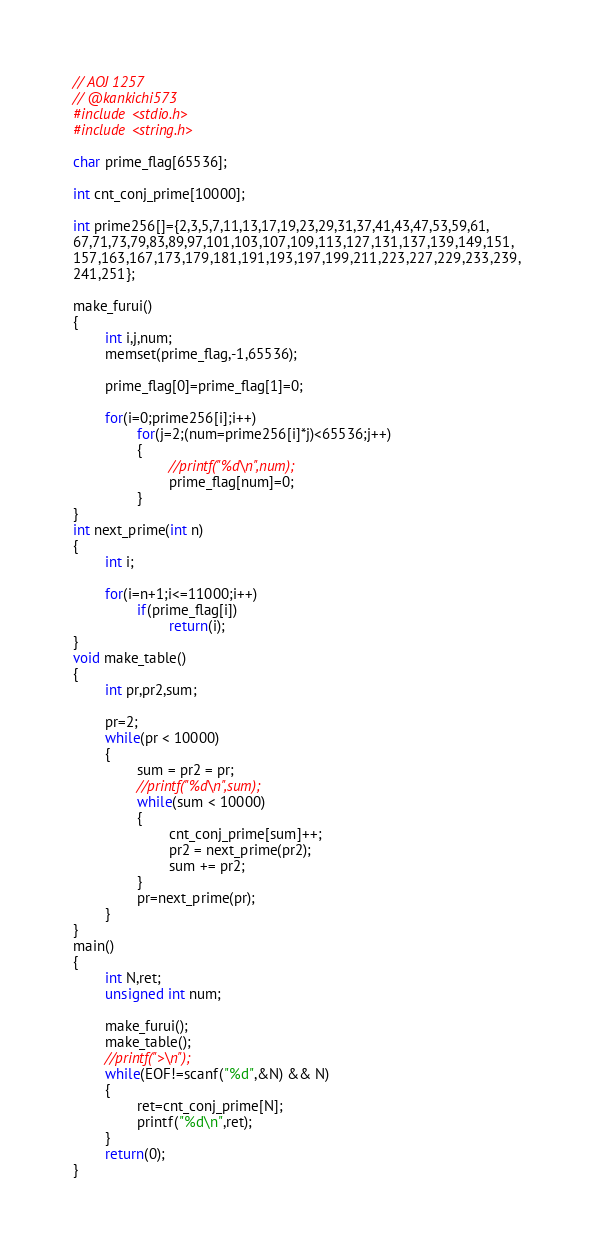Convert code to text. <code><loc_0><loc_0><loc_500><loc_500><_C_>// AOJ 1257
// @kankichi573
#include <stdio.h>
#include <string.h>

char prime_flag[65536];

int cnt_conj_prime[10000];

int prime256[]={2,3,5,7,11,13,17,19,23,29,31,37,41,43,47,53,59,61,
67,71,73,79,83,89,97,101,103,107,109,113,127,131,137,139,149,151,
157,163,167,173,179,181,191,193,197,199,211,223,227,229,233,239,
241,251};

make_furui()
{
        int i,j,num;
        memset(prime_flag,-1,65536);
        
        prime_flag[0]=prime_flag[1]=0;

        for(i=0;prime256[i];i++)
                for(j=2;(num=prime256[i]*j)<65536;j++)
                {
                        //printf("%d\n",num);
                        prime_flag[num]=0;
                }
}
int next_prime(int n)
{
        int i;

        for(i=n+1;i<=11000;i++)
                if(prime_flag[i])
                        return(i);
}
void make_table()
{
        int pr,pr2,sum;

        pr=2;
        while(pr < 10000)
        {
                sum = pr2 = pr;
                //printf("%d\n",sum);
                while(sum < 10000)
                {
                        cnt_conj_prime[sum]++;
                        pr2 = next_prime(pr2);
                        sum += pr2;
                }
                pr=next_prime(pr);
        }
}
main()
{
        int N,ret;
        unsigned int num;

        make_furui();
        make_table();
        //printf(">\n");
        while(EOF!=scanf("%d",&N) && N)
        {
                ret=cnt_conj_prime[N];
                printf("%d\n",ret);
        }
        return(0);
}</code> 